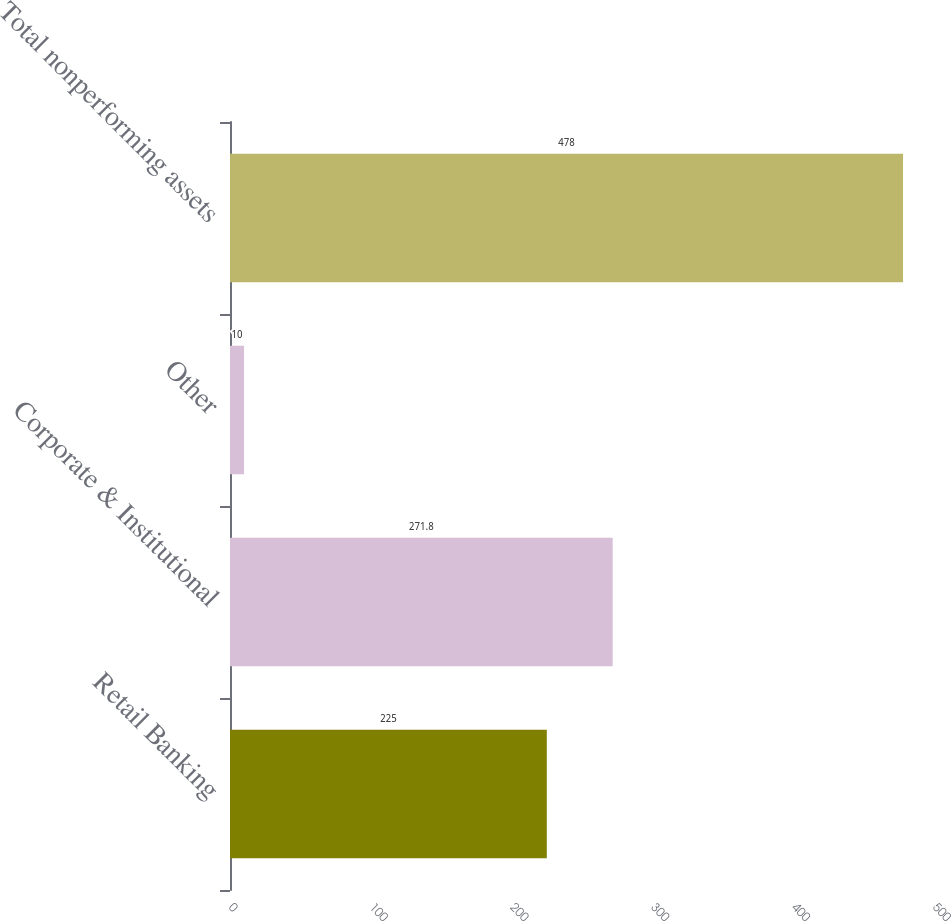<chart> <loc_0><loc_0><loc_500><loc_500><bar_chart><fcel>Retail Banking<fcel>Corporate & Institutional<fcel>Other<fcel>Total nonperforming assets<nl><fcel>225<fcel>271.8<fcel>10<fcel>478<nl></chart> 